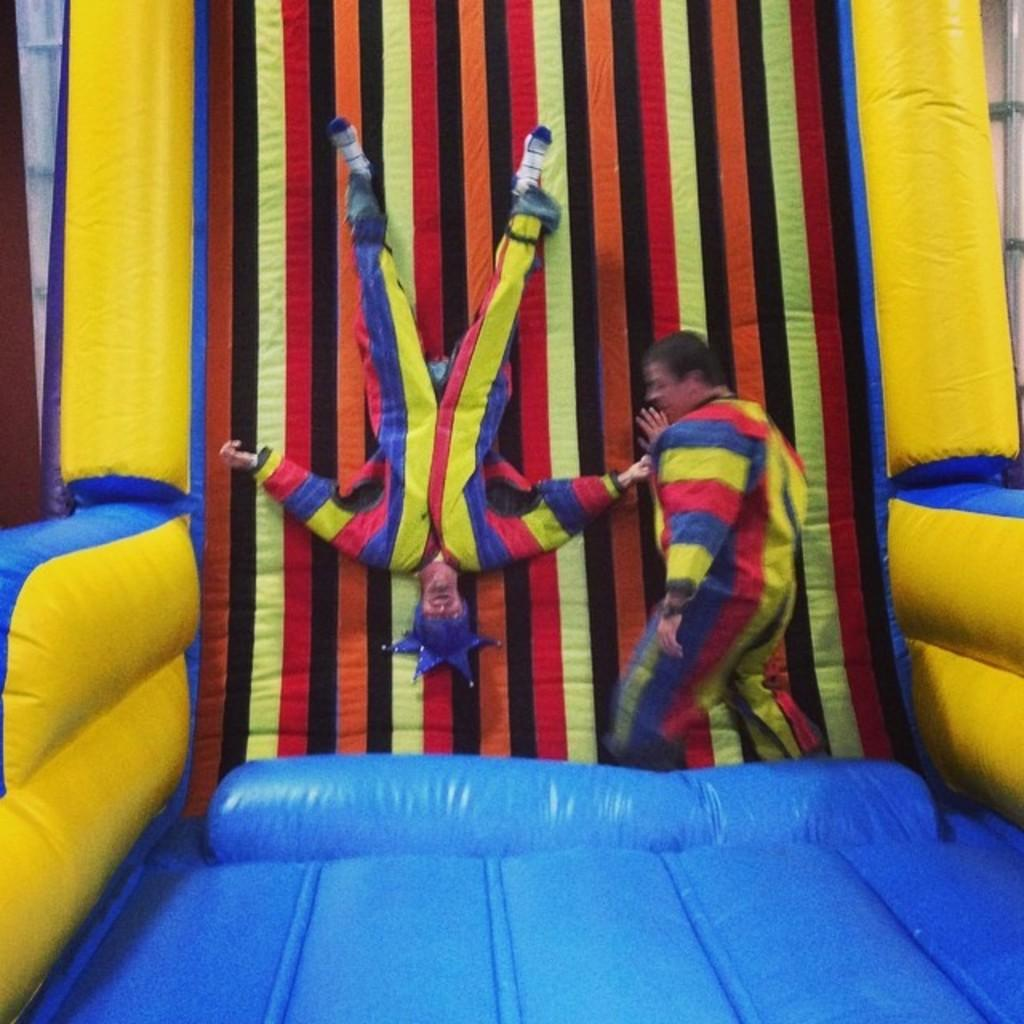How many people are present in the image? There are two persons in the image. Can you describe the background of the image? The background of the image is colorful. What type of soup is being served in the image? There is no soup present in the image; it only features two persons and a colorful background. 